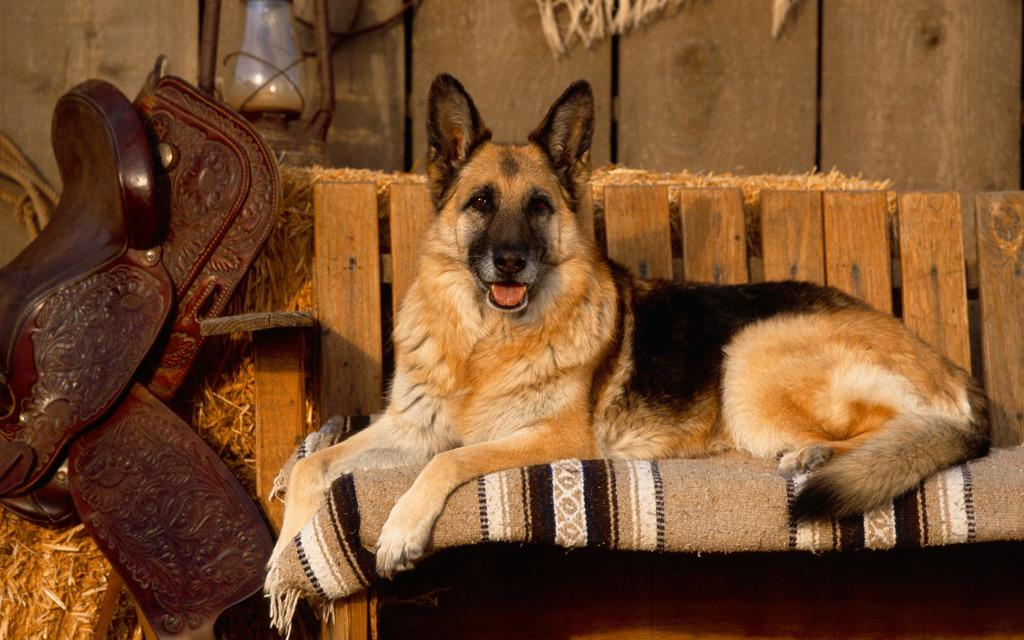What is the animal sitting on the sofa in the image? There is a dog sitting on the sofa in the image. What can be seen on the grass in the image? There is an object on the grass, and a lantern is also on the grass. What type of wall is visible in the background? There is a wooden wall in the background. What is located on the left side of the image? There is a rope on the left side of the image. What type of chalk is being used to draw on the dog in the image? There is no chalk or drawing on the dog in the image; it is simply sitting on the sofa. How does the dust affect the visibility of the wooden wall in the image? There is no mention of dust in the image, and the wooden wall is clearly visible. 